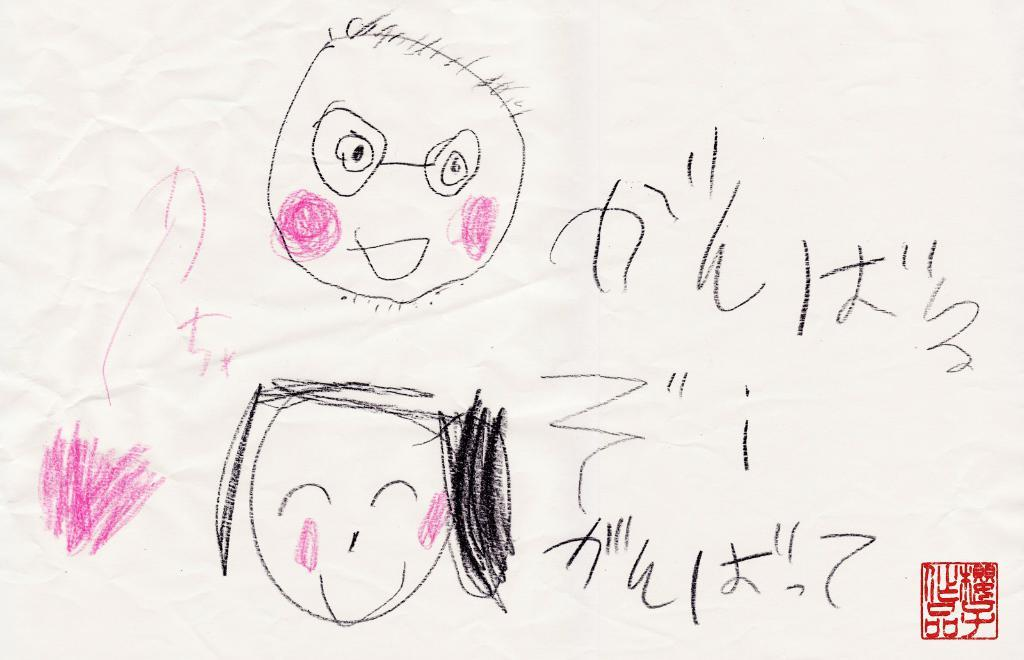What is depicted on the paper in the image? The paper contains sketches. What subjects are included in the sketches? There is a sketch of a boy and a sketch of a girl on the paper. What colors are used in the sketches? The sketches include black and pink colors. Can you describe the fog in the image? There is no fog present in the image; it only features a paper with sketches. What type of desk is visible in the image? There is no desk present in the image; it only features a paper with sketches. 